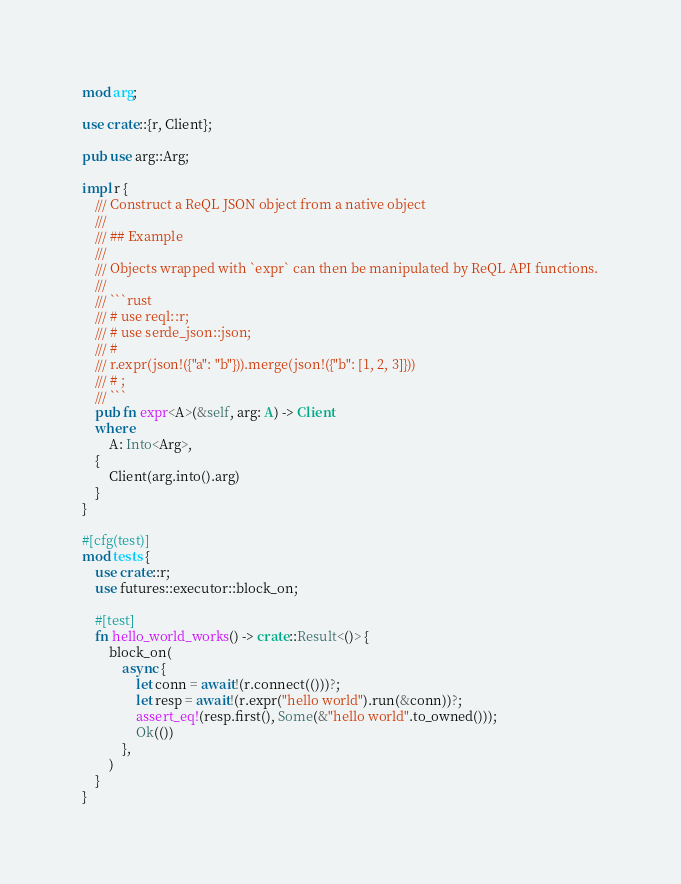<code> <loc_0><loc_0><loc_500><loc_500><_Rust_>mod arg;

use crate::{r, Client};

pub use arg::Arg;

impl r {
    /// Construct a ReQL JSON object from a native object
    ///
    /// ## Example
    ///
    /// Objects wrapped with `expr` can then be manipulated by ReQL API functions.
    ///
    /// ```rust
    /// # use reql::r;
    /// # use serde_json::json;
    /// #
    /// r.expr(json!({"a": "b"})).merge(json!({"b": [1, 2, 3]}))
    /// # ;
    /// ```
    pub fn expr<A>(&self, arg: A) -> Client
    where
        A: Into<Arg>,
    {
        Client(arg.into().arg)
    }
}

#[cfg(test)]
mod tests {
    use crate::r;
    use futures::executor::block_on;

    #[test]
    fn hello_world_works() -> crate::Result<()> {
        block_on(
            async {
                let conn = await!(r.connect(()))?;
                let resp = await!(r.expr("hello world").run(&conn))?;
                assert_eq!(resp.first(), Some(&"hello world".to_owned()));
                Ok(())
            },
        )
    }
}
</code> 